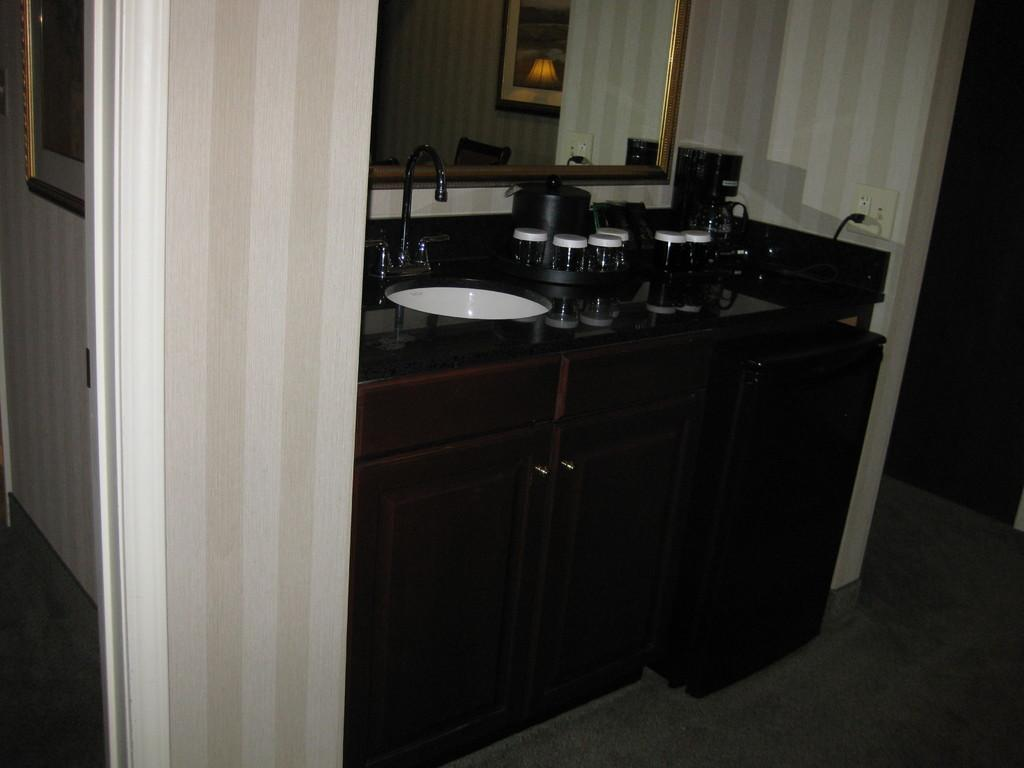What is the main object in the image? There is a washbasin in the image. What is attached to the washbasin? There is a tap in the image. What other objects can be seen in the image? There are objects in the image, including a cupboard and a frame. What is the purpose of the mirror in the image? There is a mirror attached to the wall in the image, which is likely used for personal grooming or checking one's appearance. Can you see any fish swimming in the washbasin in the image? No, there are no fish present in the image. The image features a washbasin, tap, objects, cupboard, frame, and a mirror attached to the wall, but no fish. 